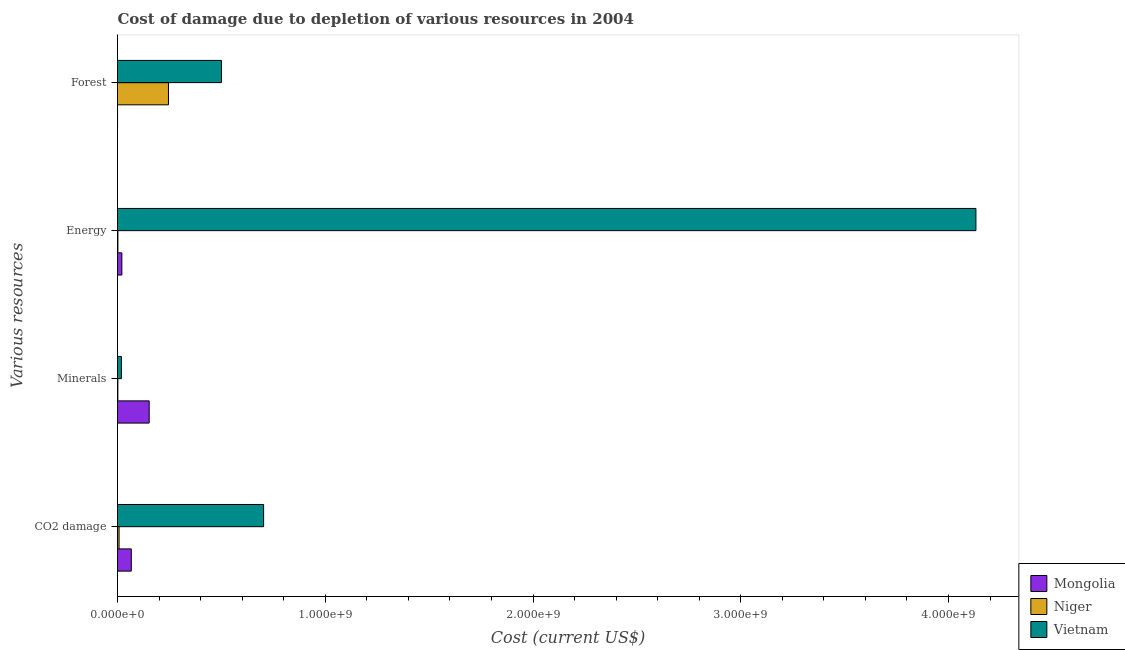How many different coloured bars are there?
Your response must be concise. 3. How many groups of bars are there?
Make the answer very short. 4. How many bars are there on the 2nd tick from the top?
Your answer should be compact. 3. How many bars are there on the 4th tick from the bottom?
Ensure brevity in your answer.  3. What is the label of the 4th group of bars from the top?
Ensure brevity in your answer.  CO2 damage. What is the cost of damage due to depletion of coal in Niger?
Make the answer very short. 7.49e+06. Across all countries, what is the maximum cost of damage due to depletion of coal?
Make the answer very short. 7.03e+08. Across all countries, what is the minimum cost of damage due to depletion of minerals?
Offer a very short reply. 1.72e+06. In which country was the cost of damage due to depletion of coal maximum?
Provide a succinct answer. Vietnam. In which country was the cost of damage due to depletion of minerals minimum?
Provide a short and direct response. Niger. What is the total cost of damage due to depletion of forests in the graph?
Your answer should be very brief. 7.46e+08. What is the difference between the cost of damage due to depletion of energy in Vietnam and that in Mongolia?
Offer a terse response. 4.11e+09. What is the difference between the cost of damage due to depletion of forests in Niger and the cost of damage due to depletion of energy in Mongolia?
Give a very brief answer. 2.24e+08. What is the average cost of damage due to depletion of minerals per country?
Make the answer very short. 5.77e+07. What is the difference between the cost of damage due to depletion of minerals and cost of damage due to depletion of energy in Niger?
Your response must be concise. -1.74e+05. In how many countries, is the cost of damage due to depletion of minerals greater than 1200000000 US$?
Ensure brevity in your answer.  0. What is the ratio of the cost of damage due to depletion of energy in Mongolia to that in Vietnam?
Make the answer very short. 0.01. What is the difference between the highest and the second highest cost of damage due to depletion of energy?
Give a very brief answer. 4.11e+09. What is the difference between the highest and the lowest cost of damage due to depletion of energy?
Offer a terse response. 4.13e+09. Is the sum of the cost of damage due to depletion of energy in Mongolia and Niger greater than the maximum cost of damage due to depletion of forests across all countries?
Make the answer very short. No. What does the 2nd bar from the top in Minerals represents?
Offer a very short reply. Niger. What does the 1st bar from the bottom in Minerals represents?
Make the answer very short. Mongolia. Is it the case that in every country, the sum of the cost of damage due to depletion of coal and cost of damage due to depletion of minerals is greater than the cost of damage due to depletion of energy?
Ensure brevity in your answer.  No. Are all the bars in the graph horizontal?
Make the answer very short. Yes. What is the difference between two consecutive major ticks on the X-axis?
Make the answer very short. 1.00e+09. Does the graph contain any zero values?
Offer a terse response. No. Where does the legend appear in the graph?
Your response must be concise. Bottom right. How many legend labels are there?
Your answer should be very brief. 3. How are the legend labels stacked?
Offer a very short reply. Vertical. What is the title of the graph?
Offer a terse response. Cost of damage due to depletion of various resources in 2004 . What is the label or title of the X-axis?
Offer a terse response. Cost (current US$). What is the label or title of the Y-axis?
Provide a short and direct response. Various resources. What is the Cost (current US$) in Mongolia in CO2 damage?
Your answer should be very brief. 6.64e+07. What is the Cost (current US$) of Niger in CO2 damage?
Give a very brief answer. 7.49e+06. What is the Cost (current US$) in Vietnam in CO2 damage?
Provide a succinct answer. 7.03e+08. What is the Cost (current US$) of Mongolia in Minerals?
Provide a short and direct response. 1.53e+08. What is the Cost (current US$) in Niger in Minerals?
Your answer should be compact. 1.72e+06. What is the Cost (current US$) of Vietnam in Minerals?
Keep it short and to the point. 1.87e+07. What is the Cost (current US$) of Mongolia in Energy?
Your response must be concise. 2.10e+07. What is the Cost (current US$) in Niger in Energy?
Your answer should be compact. 1.90e+06. What is the Cost (current US$) in Vietnam in Energy?
Offer a terse response. 4.13e+09. What is the Cost (current US$) of Mongolia in Forest?
Your response must be concise. 1.76e+05. What is the Cost (current US$) of Niger in Forest?
Provide a short and direct response. 2.45e+08. What is the Cost (current US$) in Vietnam in Forest?
Give a very brief answer. 5.00e+08. Across all Various resources, what is the maximum Cost (current US$) in Mongolia?
Make the answer very short. 1.53e+08. Across all Various resources, what is the maximum Cost (current US$) in Niger?
Provide a succinct answer. 2.45e+08. Across all Various resources, what is the maximum Cost (current US$) in Vietnam?
Offer a very short reply. 4.13e+09. Across all Various resources, what is the minimum Cost (current US$) of Mongolia?
Keep it short and to the point. 1.76e+05. Across all Various resources, what is the minimum Cost (current US$) in Niger?
Provide a short and direct response. 1.72e+06. Across all Various resources, what is the minimum Cost (current US$) of Vietnam?
Keep it short and to the point. 1.87e+07. What is the total Cost (current US$) in Mongolia in the graph?
Offer a terse response. 2.40e+08. What is the total Cost (current US$) in Niger in the graph?
Provide a short and direct response. 2.56e+08. What is the total Cost (current US$) of Vietnam in the graph?
Your response must be concise. 5.35e+09. What is the difference between the Cost (current US$) of Mongolia in CO2 damage and that in Minerals?
Keep it short and to the point. -8.61e+07. What is the difference between the Cost (current US$) of Niger in CO2 damage and that in Minerals?
Provide a succinct answer. 5.77e+06. What is the difference between the Cost (current US$) in Vietnam in CO2 damage and that in Minerals?
Provide a succinct answer. 6.85e+08. What is the difference between the Cost (current US$) in Mongolia in CO2 damage and that in Energy?
Ensure brevity in your answer.  4.54e+07. What is the difference between the Cost (current US$) of Niger in CO2 damage and that in Energy?
Provide a short and direct response. 5.59e+06. What is the difference between the Cost (current US$) in Vietnam in CO2 damage and that in Energy?
Keep it short and to the point. -3.43e+09. What is the difference between the Cost (current US$) of Mongolia in CO2 damage and that in Forest?
Ensure brevity in your answer.  6.62e+07. What is the difference between the Cost (current US$) in Niger in CO2 damage and that in Forest?
Your answer should be compact. -2.38e+08. What is the difference between the Cost (current US$) of Vietnam in CO2 damage and that in Forest?
Your answer should be very brief. 2.03e+08. What is the difference between the Cost (current US$) of Mongolia in Minerals and that in Energy?
Provide a succinct answer. 1.32e+08. What is the difference between the Cost (current US$) in Niger in Minerals and that in Energy?
Offer a very short reply. -1.74e+05. What is the difference between the Cost (current US$) of Vietnam in Minerals and that in Energy?
Your answer should be very brief. -4.11e+09. What is the difference between the Cost (current US$) in Mongolia in Minerals and that in Forest?
Ensure brevity in your answer.  1.52e+08. What is the difference between the Cost (current US$) in Niger in Minerals and that in Forest?
Keep it short and to the point. -2.44e+08. What is the difference between the Cost (current US$) of Vietnam in Minerals and that in Forest?
Provide a short and direct response. -4.82e+08. What is the difference between the Cost (current US$) in Mongolia in Energy and that in Forest?
Offer a terse response. 2.08e+07. What is the difference between the Cost (current US$) of Niger in Energy and that in Forest?
Your response must be concise. -2.43e+08. What is the difference between the Cost (current US$) of Vietnam in Energy and that in Forest?
Make the answer very short. 3.63e+09. What is the difference between the Cost (current US$) in Mongolia in CO2 damage and the Cost (current US$) in Niger in Minerals?
Provide a short and direct response. 6.47e+07. What is the difference between the Cost (current US$) of Mongolia in CO2 damage and the Cost (current US$) of Vietnam in Minerals?
Keep it short and to the point. 4.77e+07. What is the difference between the Cost (current US$) of Niger in CO2 damage and the Cost (current US$) of Vietnam in Minerals?
Keep it short and to the point. -1.12e+07. What is the difference between the Cost (current US$) of Mongolia in CO2 damage and the Cost (current US$) of Niger in Energy?
Your response must be concise. 6.45e+07. What is the difference between the Cost (current US$) in Mongolia in CO2 damage and the Cost (current US$) in Vietnam in Energy?
Make the answer very short. -4.07e+09. What is the difference between the Cost (current US$) of Niger in CO2 damage and the Cost (current US$) of Vietnam in Energy?
Ensure brevity in your answer.  -4.12e+09. What is the difference between the Cost (current US$) of Mongolia in CO2 damage and the Cost (current US$) of Niger in Forest?
Provide a succinct answer. -1.79e+08. What is the difference between the Cost (current US$) of Mongolia in CO2 damage and the Cost (current US$) of Vietnam in Forest?
Offer a very short reply. -4.34e+08. What is the difference between the Cost (current US$) of Niger in CO2 damage and the Cost (current US$) of Vietnam in Forest?
Provide a succinct answer. -4.93e+08. What is the difference between the Cost (current US$) in Mongolia in Minerals and the Cost (current US$) in Niger in Energy?
Offer a terse response. 1.51e+08. What is the difference between the Cost (current US$) of Mongolia in Minerals and the Cost (current US$) of Vietnam in Energy?
Provide a short and direct response. -3.98e+09. What is the difference between the Cost (current US$) of Niger in Minerals and the Cost (current US$) of Vietnam in Energy?
Keep it short and to the point. -4.13e+09. What is the difference between the Cost (current US$) in Mongolia in Minerals and the Cost (current US$) in Niger in Forest?
Give a very brief answer. -9.28e+07. What is the difference between the Cost (current US$) of Mongolia in Minerals and the Cost (current US$) of Vietnam in Forest?
Offer a terse response. -3.48e+08. What is the difference between the Cost (current US$) in Niger in Minerals and the Cost (current US$) in Vietnam in Forest?
Offer a terse response. -4.99e+08. What is the difference between the Cost (current US$) in Mongolia in Energy and the Cost (current US$) in Niger in Forest?
Keep it short and to the point. -2.24e+08. What is the difference between the Cost (current US$) of Mongolia in Energy and the Cost (current US$) of Vietnam in Forest?
Your response must be concise. -4.79e+08. What is the difference between the Cost (current US$) of Niger in Energy and the Cost (current US$) of Vietnam in Forest?
Your response must be concise. -4.98e+08. What is the average Cost (current US$) in Mongolia per Various resources?
Offer a very short reply. 6.00e+07. What is the average Cost (current US$) in Niger per Various resources?
Offer a very short reply. 6.41e+07. What is the average Cost (current US$) in Vietnam per Various resources?
Offer a terse response. 1.34e+09. What is the difference between the Cost (current US$) in Mongolia and Cost (current US$) in Niger in CO2 damage?
Give a very brief answer. 5.89e+07. What is the difference between the Cost (current US$) of Mongolia and Cost (current US$) of Vietnam in CO2 damage?
Your answer should be compact. -6.37e+08. What is the difference between the Cost (current US$) in Niger and Cost (current US$) in Vietnam in CO2 damage?
Provide a succinct answer. -6.96e+08. What is the difference between the Cost (current US$) of Mongolia and Cost (current US$) of Niger in Minerals?
Give a very brief answer. 1.51e+08. What is the difference between the Cost (current US$) of Mongolia and Cost (current US$) of Vietnam in Minerals?
Keep it short and to the point. 1.34e+08. What is the difference between the Cost (current US$) of Niger and Cost (current US$) of Vietnam in Minerals?
Your answer should be compact. -1.70e+07. What is the difference between the Cost (current US$) in Mongolia and Cost (current US$) in Niger in Energy?
Give a very brief answer. 1.91e+07. What is the difference between the Cost (current US$) in Mongolia and Cost (current US$) in Vietnam in Energy?
Your response must be concise. -4.11e+09. What is the difference between the Cost (current US$) in Niger and Cost (current US$) in Vietnam in Energy?
Your answer should be very brief. -4.13e+09. What is the difference between the Cost (current US$) of Mongolia and Cost (current US$) of Niger in Forest?
Provide a short and direct response. -2.45e+08. What is the difference between the Cost (current US$) of Mongolia and Cost (current US$) of Vietnam in Forest?
Provide a short and direct response. -5.00e+08. What is the difference between the Cost (current US$) in Niger and Cost (current US$) in Vietnam in Forest?
Make the answer very short. -2.55e+08. What is the ratio of the Cost (current US$) in Mongolia in CO2 damage to that in Minerals?
Provide a short and direct response. 0.44. What is the ratio of the Cost (current US$) in Niger in CO2 damage to that in Minerals?
Provide a short and direct response. 4.35. What is the ratio of the Cost (current US$) in Vietnam in CO2 damage to that in Minerals?
Make the answer very short. 37.54. What is the ratio of the Cost (current US$) in Mongolia in CO2 damage to that in Energy?
Offer a very short reply. 3.17. What is the ratio of the Cost (current US$) in Niger in CO2 damage to that in Energy?
Provide a succinct answer. 3.95. What is the ratio of the Cost (current US$) of Vietnam in CO2 damage to that in Energy?
Offer a very short reply. 0.17. What is the ratio of the Cost (current US$) in Mongolia in CO2 damage to that in Forest?
Your response must be concise. 376.41. What is the ratio of the Cost (current US$) of Niger in CO2 damage to that in Forest?
Give a very brief answer. 0.03. What is the ratio of the Cost (current US$) in Vietnam in CO2 damage to that in Forest?
Offer a very short reply. 1.41. What is the ratio of the Cost (current US$) in Mongolia in Minerals to that in Energy?
Offer a very short reply. 7.27. What is the ratio of the Cost (current US$) in Niger in Minerals to that in Energy?
Offer a very short reply. 0.91. What is the ratio of the Cost (current US$) in Vietnam in Minerals to that in Energy?
Your response must be concise. 0. What is the ratio of the Cost (current US$) in Mongolia in Minerals to that in Forest?
Make the answer very short. 864.26. What is the ratio of the Cost (current US$) of Niger in Minerals to that in Forest?
Provide a short and direct response. 0.01. What is the ratio of the Cost (current US$) of Vietnam in Minerals to that in Forest?
Make the answer very short. 0.04. What is the ratio of the Cost (current US$) of Mongolia in Energy to that in Forest?
Keep it short and to the point. 118.86. What is the ratio of the Cost (current US$) in Niger in Energy to that in Forest?
Ensure brevity in your answer.  0.01. What is the ratio of the Cost (current US$) of Vietnam in Energy to that in Forest?
Offer a very short reply. 8.26. What is the difference between the highest and the second highest Cost (current US$) in Mongolia?
Your response must be concise. 8.61e+07. What is the difference between the highest and the second highest Cost (current US$) of Niger?
Provide a succinct answer. 2.38e+08. What is the difference between the highest and the second highest Cost (current US$) in Vietnam?
Ensure brevity in your answer.  3.43e+09. What is the difference between the highest and the lowest Cost (current US$) of Mongolia?
Make the answer very short. 1.52e+08. What is the difference between the highest and the lowest Cost (current US$) of Niger?
Make the answer very short. 2.44e+08. What is the difference between the highest and the lowest Cost (current US$) in Vietnam?
Keep it short and to the point. 4.11e+09. 